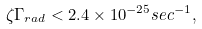Convert formula to latex. <formula><loc_0><loc_0><loc_500><loc_500>\zeta \Gamma _ { r a d } < 2 . 4 \times 1 0 ^ { - 2 5 } s e c ^ { - 1 } ,</formula> 